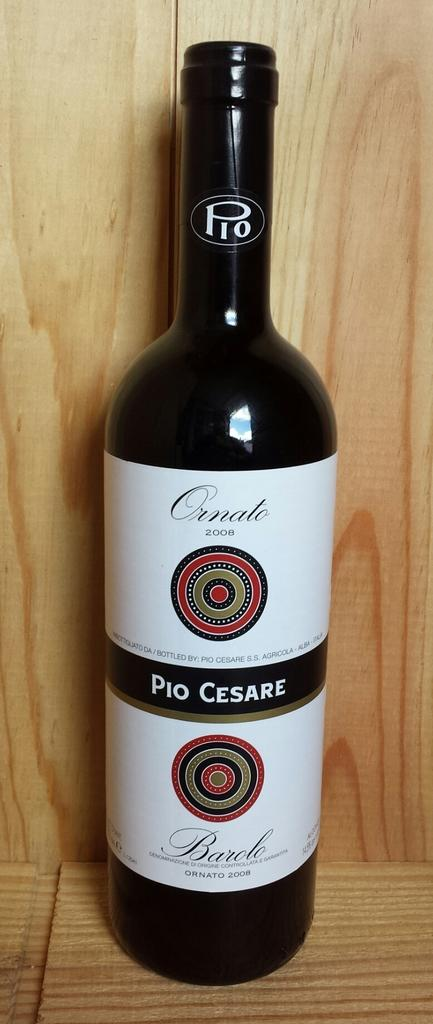Provide a one-sentence caption for the provided image. a wine bottle named Pio Cesare with a white label. 